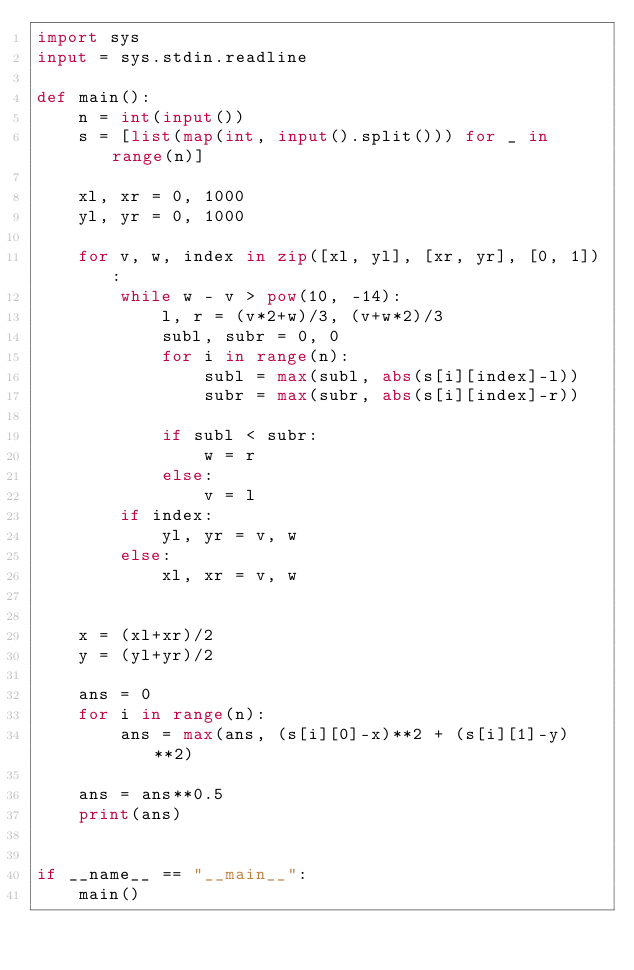<code> <loc_0><loc_0><loc_500><loc_500><_Python_>import sys
input = sys.stdin.readline

def main():
    n = int(input())
    s = [list(map(int, input().split())) for _ in range(n)]
    
    xl, xr = 0, 1000
    yl, yr = 0, 1000
    
    for v, w, index in zip([xl, yl], [xr, yr], [0, 1]):
        while w - v > pow(10, -14):
            l, r = (v*2+w)/3, (v+w*2)/3
            subl, subr = 0, 0
            for i in range(n):
                subl = max(subl, abs(s[i][index]-l))
                subr = max(subr, abs(s[i][index]-r))
            
            if subl < subr:
                w = r
            else:
                v = l
        if index:
            yl, yr = v, w
        else:
            xl, xr = v, w
        
    
    x = (xl+xr)/2
    y = (yl+yr)/2
    
    ans = 0
    for i in range(n):
        ans = max(ans, (s[i][0]-x)**2 + (s[i][1]-y)**2)
    
    ans = ans**0.5
    print(ans)
        
    
if __name__ == "__main__":
    main()
</code> 